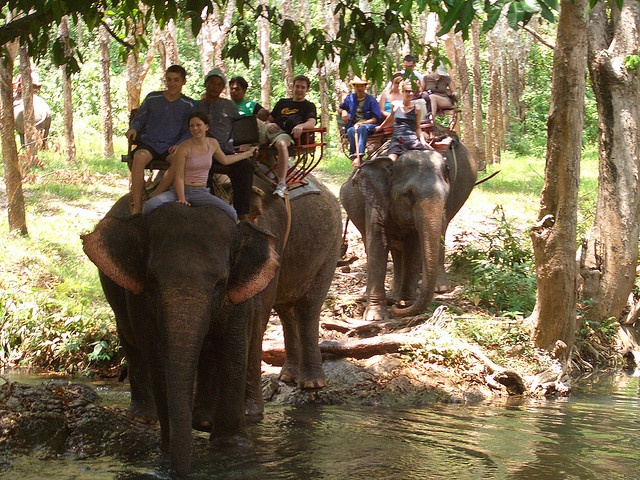Describe the objects in this image and their specific colors. I can see elephant in black, maroon, and gray tones, elephant in black, gray, and maroon tones, people in black, maroon, and gray tones, people in black, gray, and brown tones, and people in black, maroon, and gray tones in this image. 